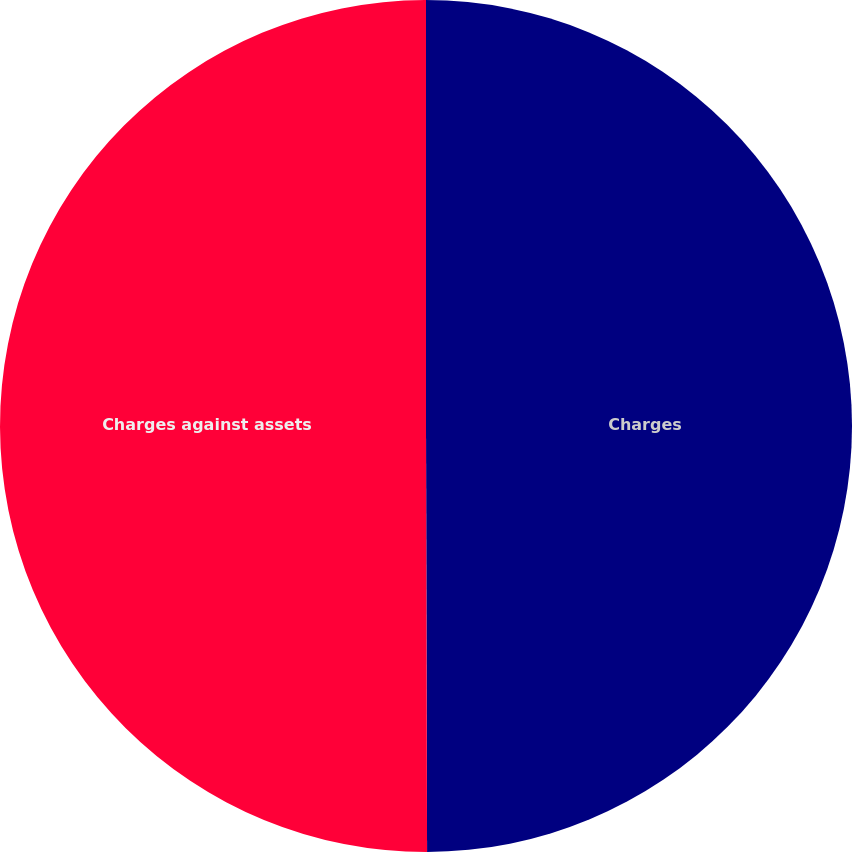Convert chart to OTSL. <chart><loc_0><loc_0><loc_500><loc_500><pie_chart><fcel>Charges<fcel>Charges against assets<nl><fcel>49.96%<fcel>50.04%<nl></chart> 